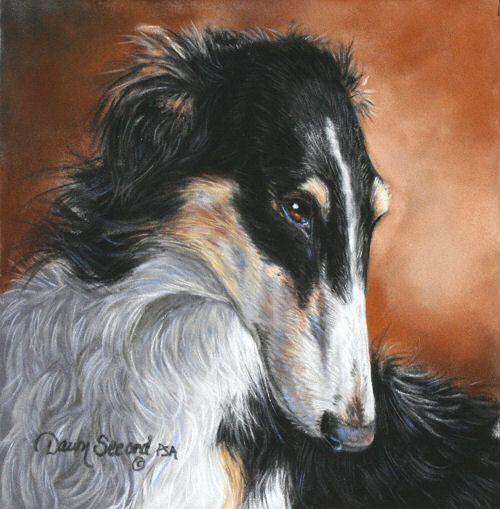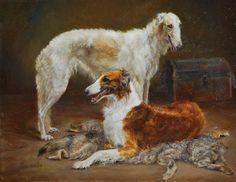The first image is the image on the left, the second image is the image on the right. Assess this claim about the two images: "In one image there is a lone Russian Wolfhound standing with its nose pointing to the left of the image.". Correct or not? Answer yes or no. No. The first image is the image on the left, the second image is the image on the right. Considering the images on both sides, is "The right image contains a painting with two dogs." valid? Answer yes or no. Yes. 